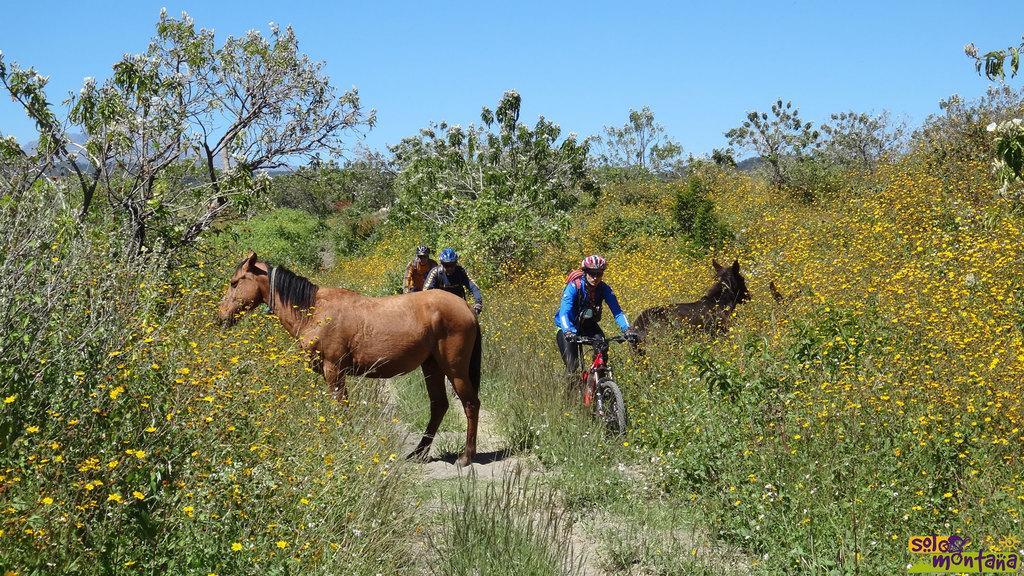Could you give a brief overview of what you see in this image? This picture is taken from outside of the city. In this image, in the middle, we can see a horse standing on the land. On the right side, we can also see another horse standing on the plants. In the middle of the image, we can see three people are riding a bicycle. In the background, we can see some trees and plants. At the top, we can see a sky, at the bottom, we can see a plant with some flowers and a land. 